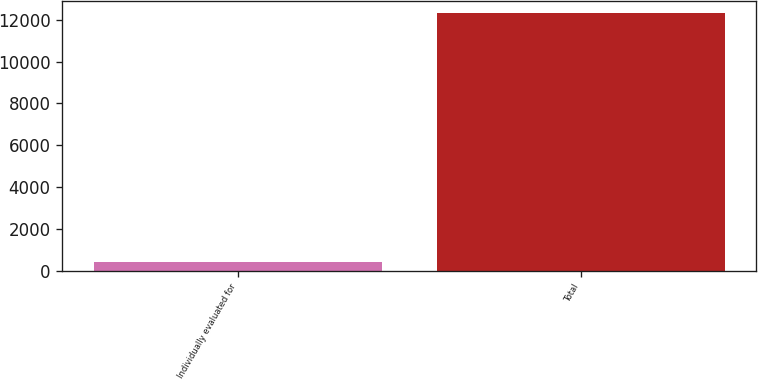Convert chart. <chart><loc_0><loc_0><loc_500><loc_500><bar_chart><fcel>Individually evaluated for<fcel>Total<nl><fcel>422<fcel>12307<nl></chart> 